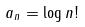<formula> <loc_0><loc_0><loc_500><loc_500>a _ { n } = \log n !</formula> 